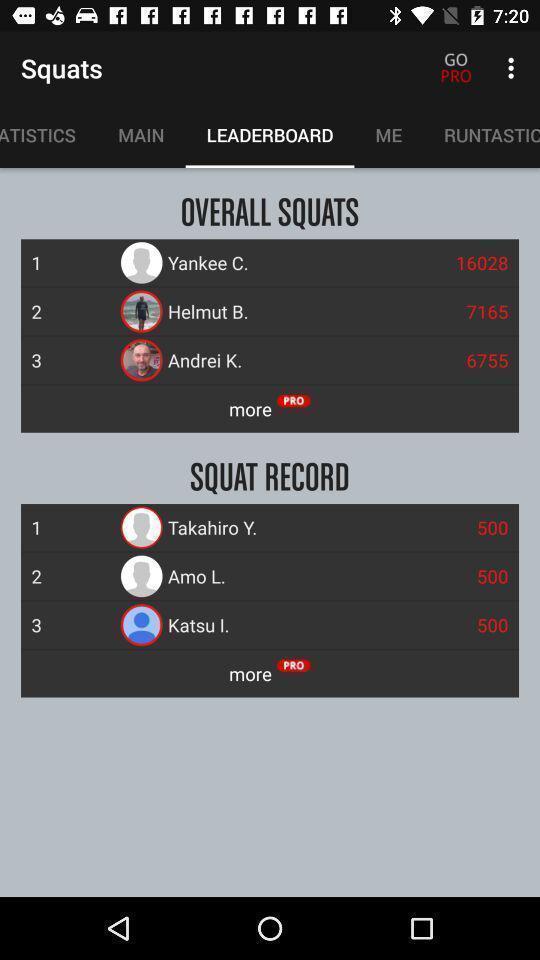Describe the visual elements of this screenshot. Screen display leader board page. 